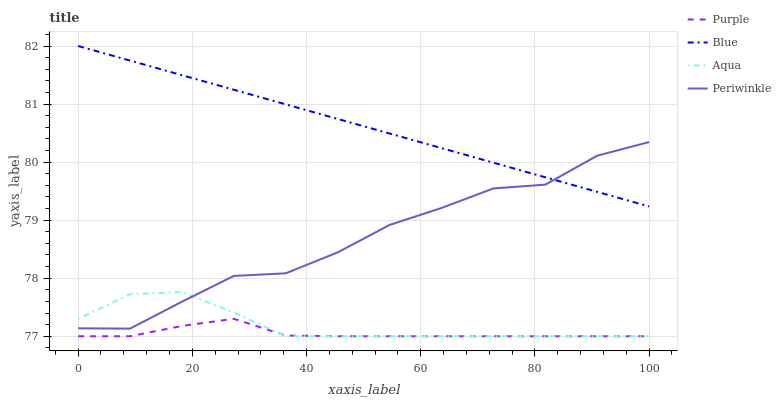Does Purple have the minimum area under the curve?
Answer yes or no. Yes. Does Blue have the maximum area under the curve?
Answer yes or no. Yes. Does Periwinkle have the minimum area under the curve?
Answer yes or no. No. Does Periwinkle have the maximum area under the curve?
Answer yes or no. No. Is Blue the smoothest?
Answer yes or no. Yes. Is Periwinkle the roughest?
Answer yes or no. Yes. Is Periwinkle the smoothest?
Answer yes or no. No. Is Blue the roughest?
Answer yes or no. No. Does Purple have the lowest value?
Answer yes or no. Yes. Does Periwinkle have the lowest value?
Answer yes or no. No. Does Blue have the highest value?
Answer yes or no. Yes. Does Periwinkle have the highest value?
Answer yes or no. No. Is Purple less than Periwinkle?
Answer yes or no. Yes. Is Blue greater than Purple?
Answer yes or no. Yes. Does Periwinkle intersect Aqua?
Answer yes or no. Yes. Is Periwinkle less than Aqua?
Answer yes or no. No. Is Periwinkle greater than Aqua?
Answer yes or no. No. Does Purple intersect Periwinkle?
Answer yes or no. No. 